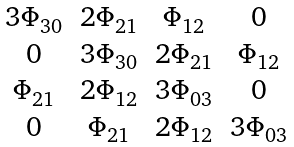<formula> <loc_0><loc_0><loc_500><loc_500>\begin{matrix} 3 \Phi _ { 3 0 } & 2 \Phi _ { 2 1 } & \Phi _ { 1 2 } & 0 \\ 0 & 3 \Phi _ { 3 0 } & 2 \Phi _ { 2 1 } & \Phi _ { 1 2 } \\ \Phi _ { 2 1 } & 2 \Phi _ { 1 2 } & 3 \Phi _ { 0 3 } & 0 \\ 0 & \Phi _ { 2 1 } & 2 \Phi _ { 1 2 } & 3 \Phi _ { 0 3 } \end{matrix}</formula> 